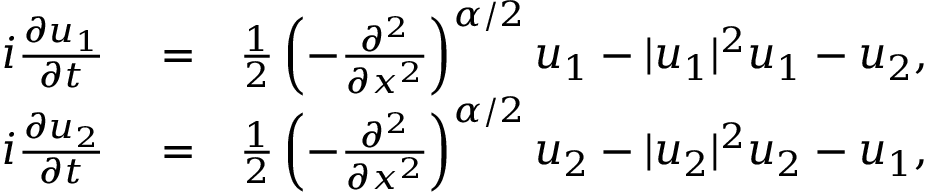<formula> <loc_0><loc_0><loc_500><loc_500>\begin{array} { r l r } { i \frac { \partial u _ { 1 } } { \partial t } } & = } & { \frac { 1 } { 2 } \left ( - \frac { \partial ^ { 2 } } { \partial x ^ { 2 } } \right ) ^ { \alpha / 2 } u _ { 1 } - | u _ { 1 } | ^ { 2 } u _ { 1 } - u _ { 2 } , } \\ { i \frac { \partial u _ { 2 } } { \partial t } } & = } & { \frac { 1 } { 2 } \left ( - \frac { \partial ^ { 2 } } { \partial x ^ { 2 } } \right ) ^ { \alpha / 2 } u _ { 2 } - | u _ { 2 } | ^ { 2 } u _ { 2 } - u _ { 1 } , } \end{array}</formula> 